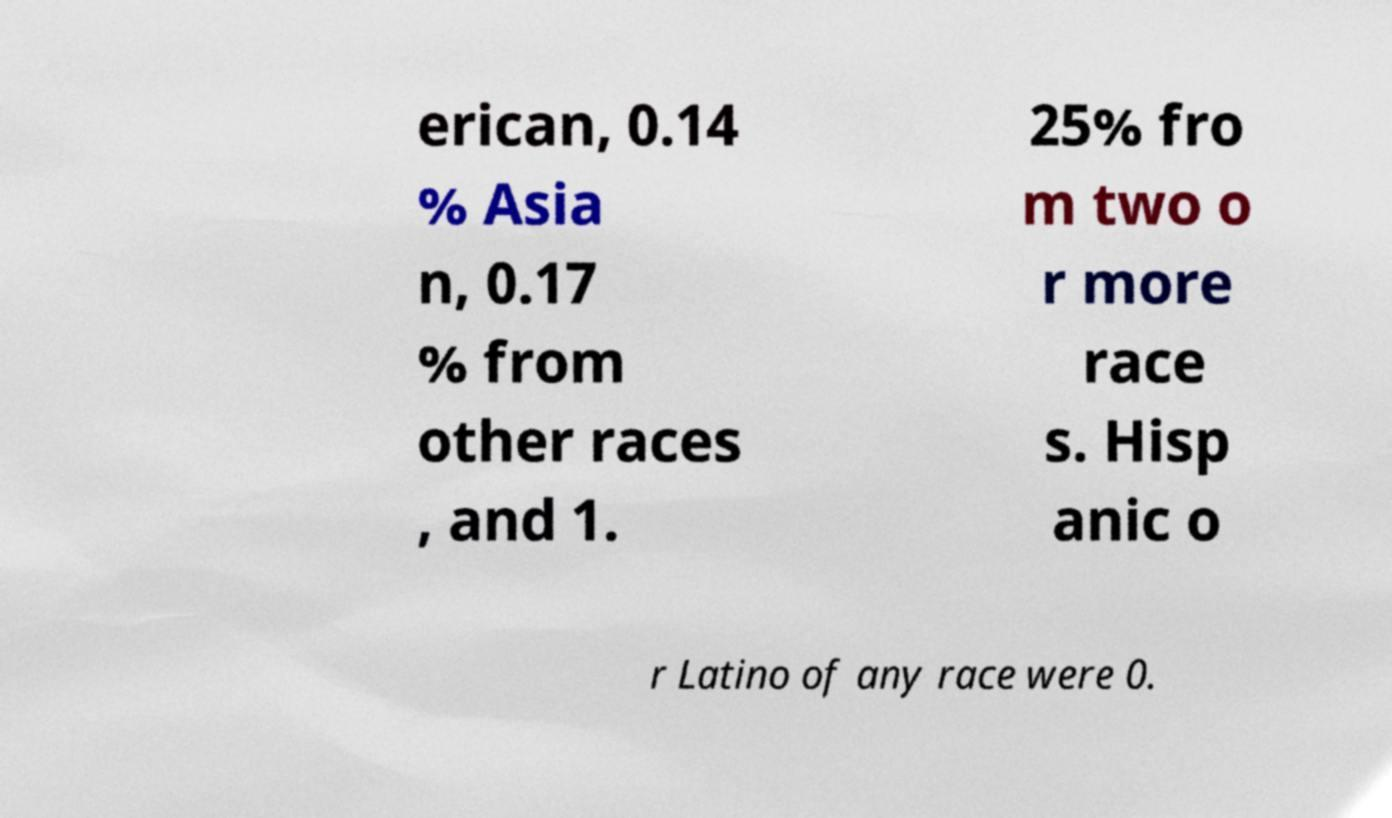What messages or text are displayed in this image? I need them in a readable, typed format. erican, 0.14 % Asia n, 0.17 % from other races , and 1. 25% fro m two o r more race s. Hisp anic o r Latino of any race were 0. 